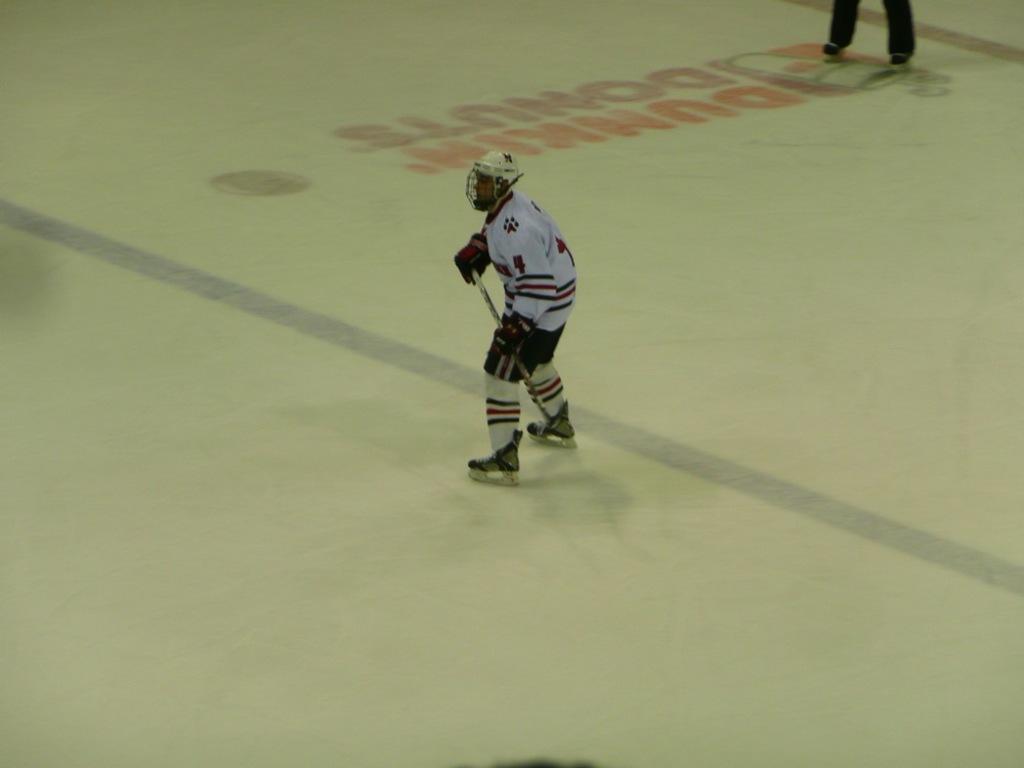What number is the player?
Keep it short and to the point. 4. 